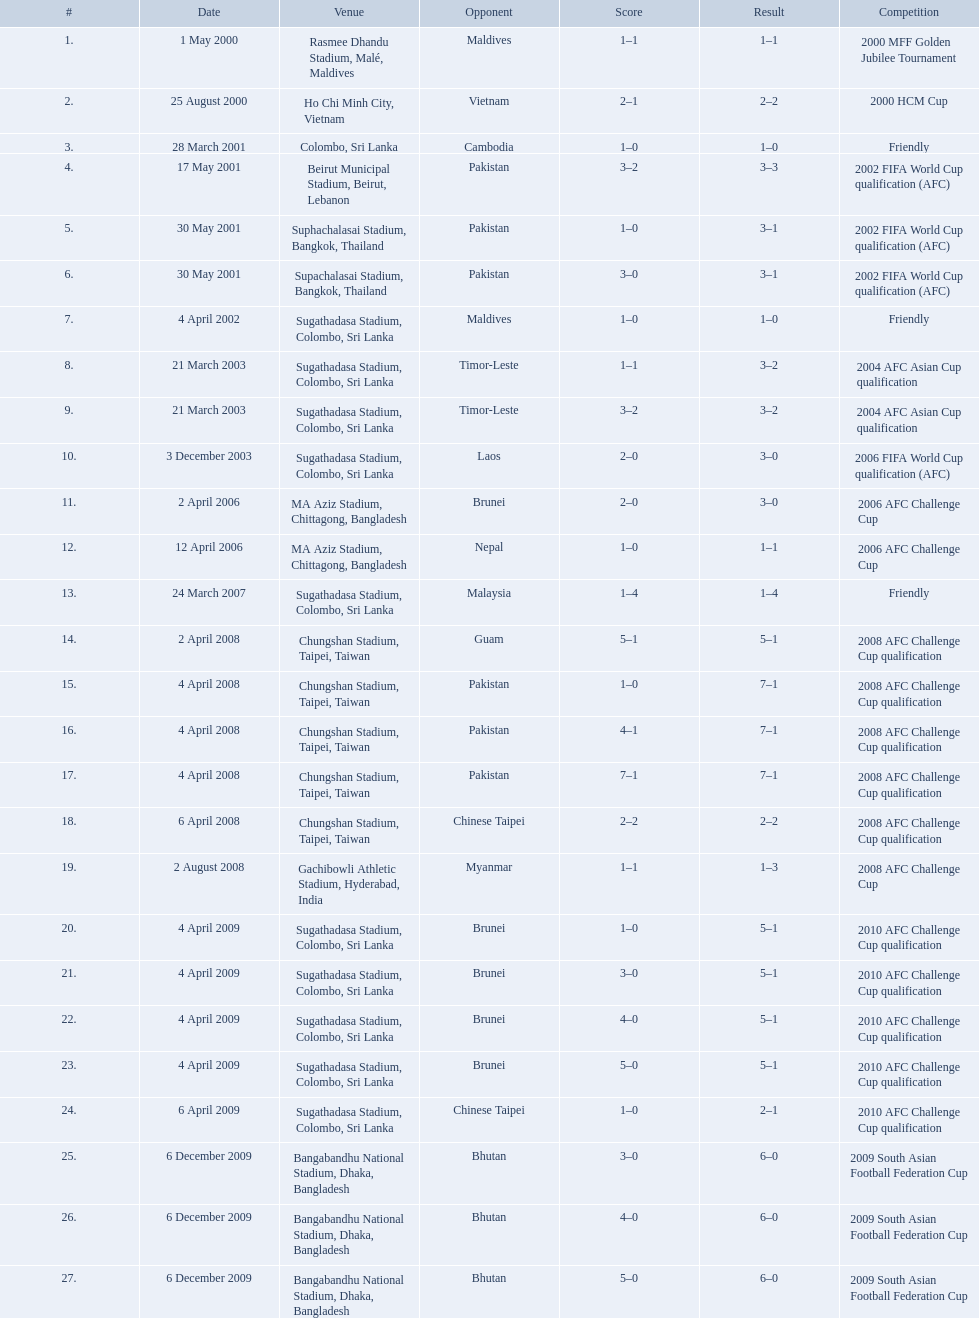How many venues are in the table? 27. Which one is the top listed? Rasmee Dhandu Stadium, Malé, Maldives. Which venues are included in the list? Rasmee Dhandu Stadium, Malé, Maldives, Ho Chi Minh City, Vietnam, Colombo, Sri Lanka, Beirut Municipal Stadium, Beirut, Lebanon, Suphachalasai Stadium, Bangkok, Thailand, MA Aziz Stadium, Chittagong, Bangladesh, Sugathadasa Stadium, Colombo, Sri Lanka, Chungshan Stadium, Taipei, Taiwan, Gachibowli Athletic Stadium, Hyderabad, India, Sugathadasa Stadium, Colombo, Sri Lanka, Bangabandhu National Stadium, Dhaka, Bangladesh. Which one has the top position? Rasmee Dhandu Stadium, Malé, Maldives. 